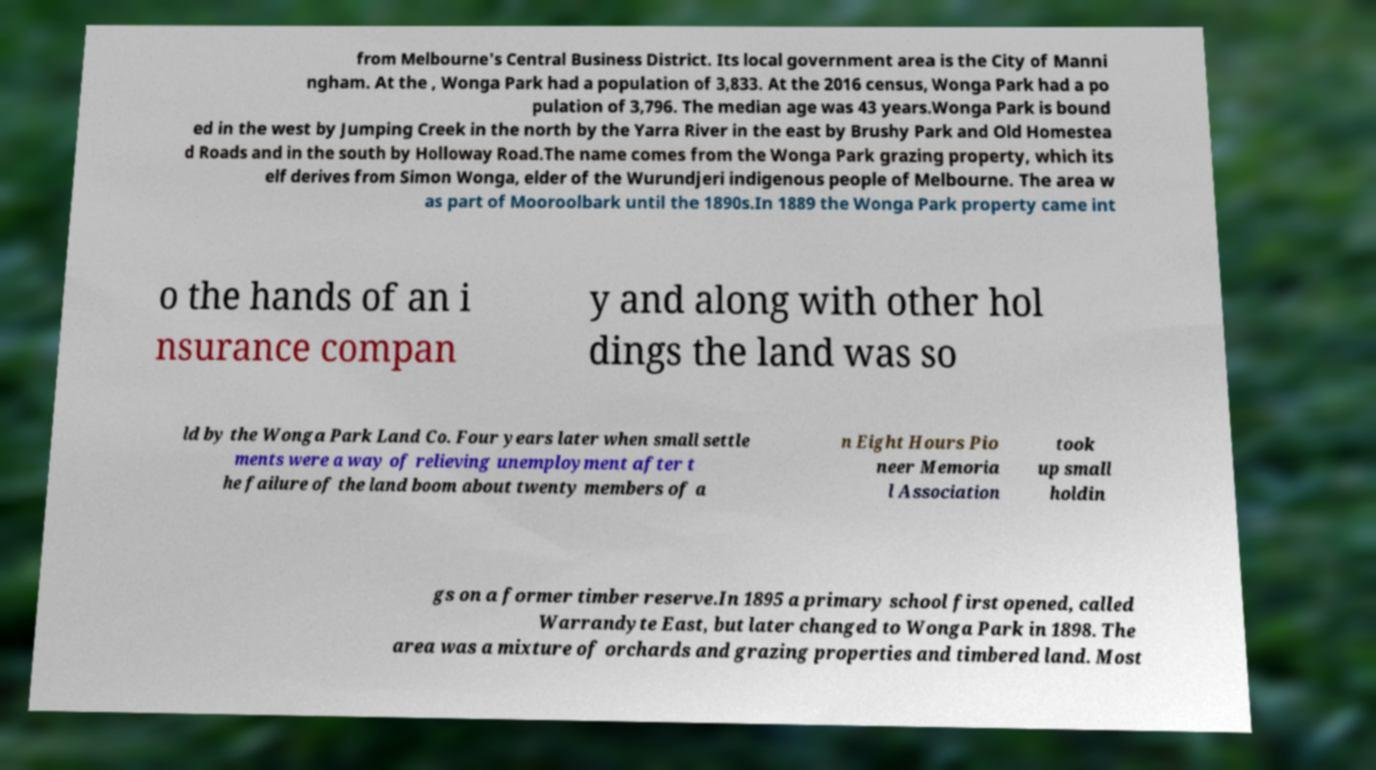I need the written content from this picture converted into text. Can you do that? from Melbourne's Central Business District. Its local government area is the City of Manni ngham. At the , Wonga Park had a population of 3,833. At the 2016 census, Wonga Park had a po pulation of 3,796. The median age was 43 years.Wonga Park is bound ed in the west by Jumping Creek in the north by the Yarra River in the east by Brushy Park and Old Homestea d Roads and in the south by Holloway Road.The name comes from the Wonga Park grazing property, which its elf derives from Simon Wonga, elder of the Wurundjeri indigenous people of Melbourne. The area w as part of Mooroolbark until the 1890s.In 1889 the Wonga Park property came int o the hands of an i nsurance compan y and along with other hol dings the land was so ld by the Wonga Park Land Co. Four years later when small settle ments were a way of relieving unemployment after t he failure of the land boom about twenty members of a n Eight Hours Pio neer Memoria l Association took up small holdin gs on a former timber reserve.In 1895 a primary school first opened, called Warrandyte East, but later changed to Wonga Park in 1898. The area was a mixture of orchards and grazing properties and timbered land. Most 